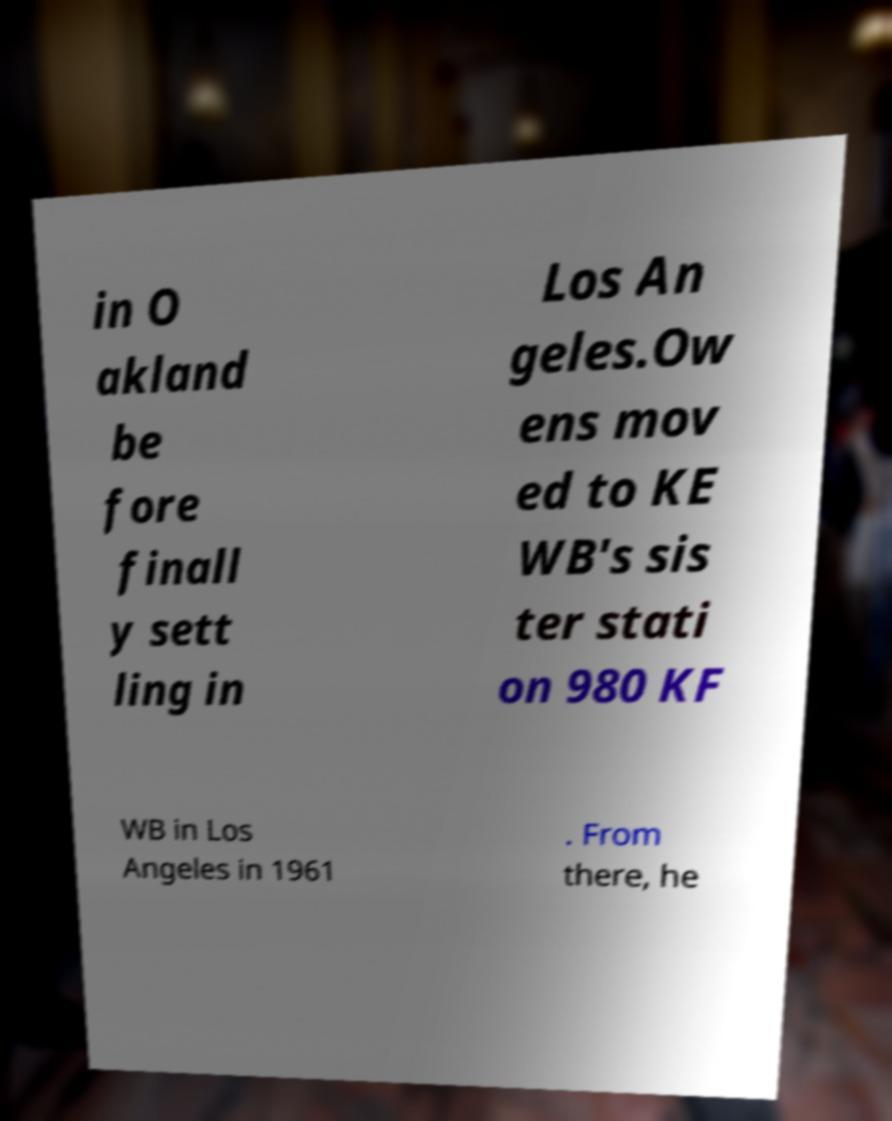Can you accurately transcribe the text from the provided image for me? in O akland be fore finall y sett ling in Los An geles.Ow ens mov ed to KE WB's sis ter stati on 980 KF WB in Los Angeles in 1961 . From there, he 